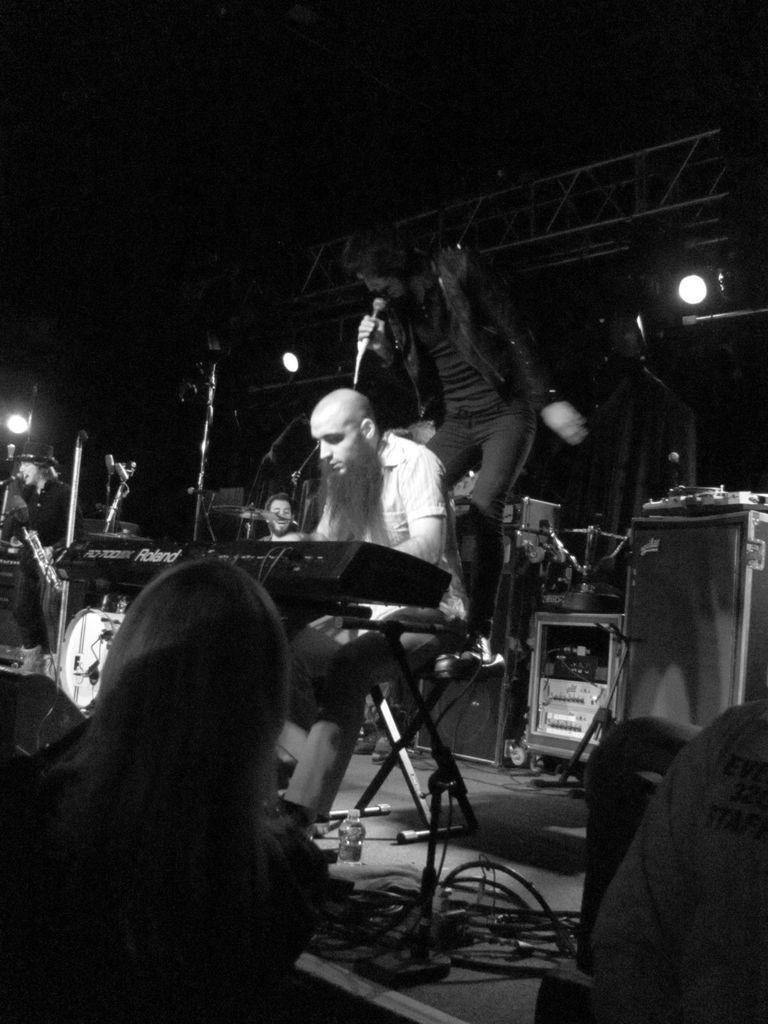What are the people on the stage doing? The people on the stage are playing musical instruments and singing. Can you describe the activities of the people on the stage? The people are sitting and standing on the stage, playing musical instruments, and singing. How many beetles can be seen crawling on the stage in the image? There are no beetles visible in the image; it features people playing musical instruments and singing. What type of sorting activity is taking place on the stage in the image? There is no sorting activity present in the image; it features people playing musical instruments and singing. 